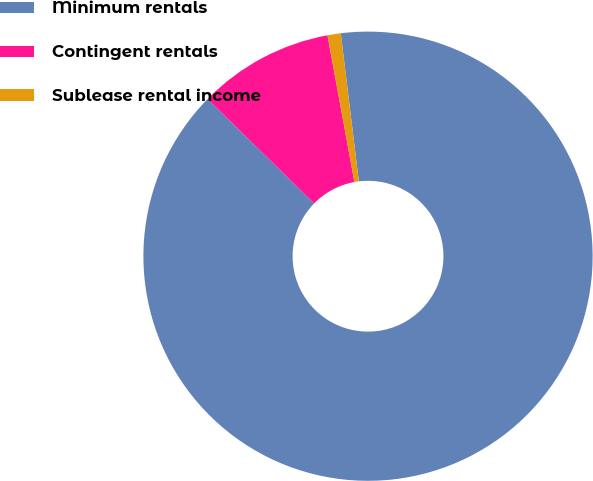<chart> <loc_0><loc_0><loc_500><loc_500><pie_chart><fcel>Minimum rentals<fcel>Contingent rentals<fcel>Sublease rental income<nl><fcel>89.27%<fcel>9.78%<fcel>0.95%<nl></chart> 